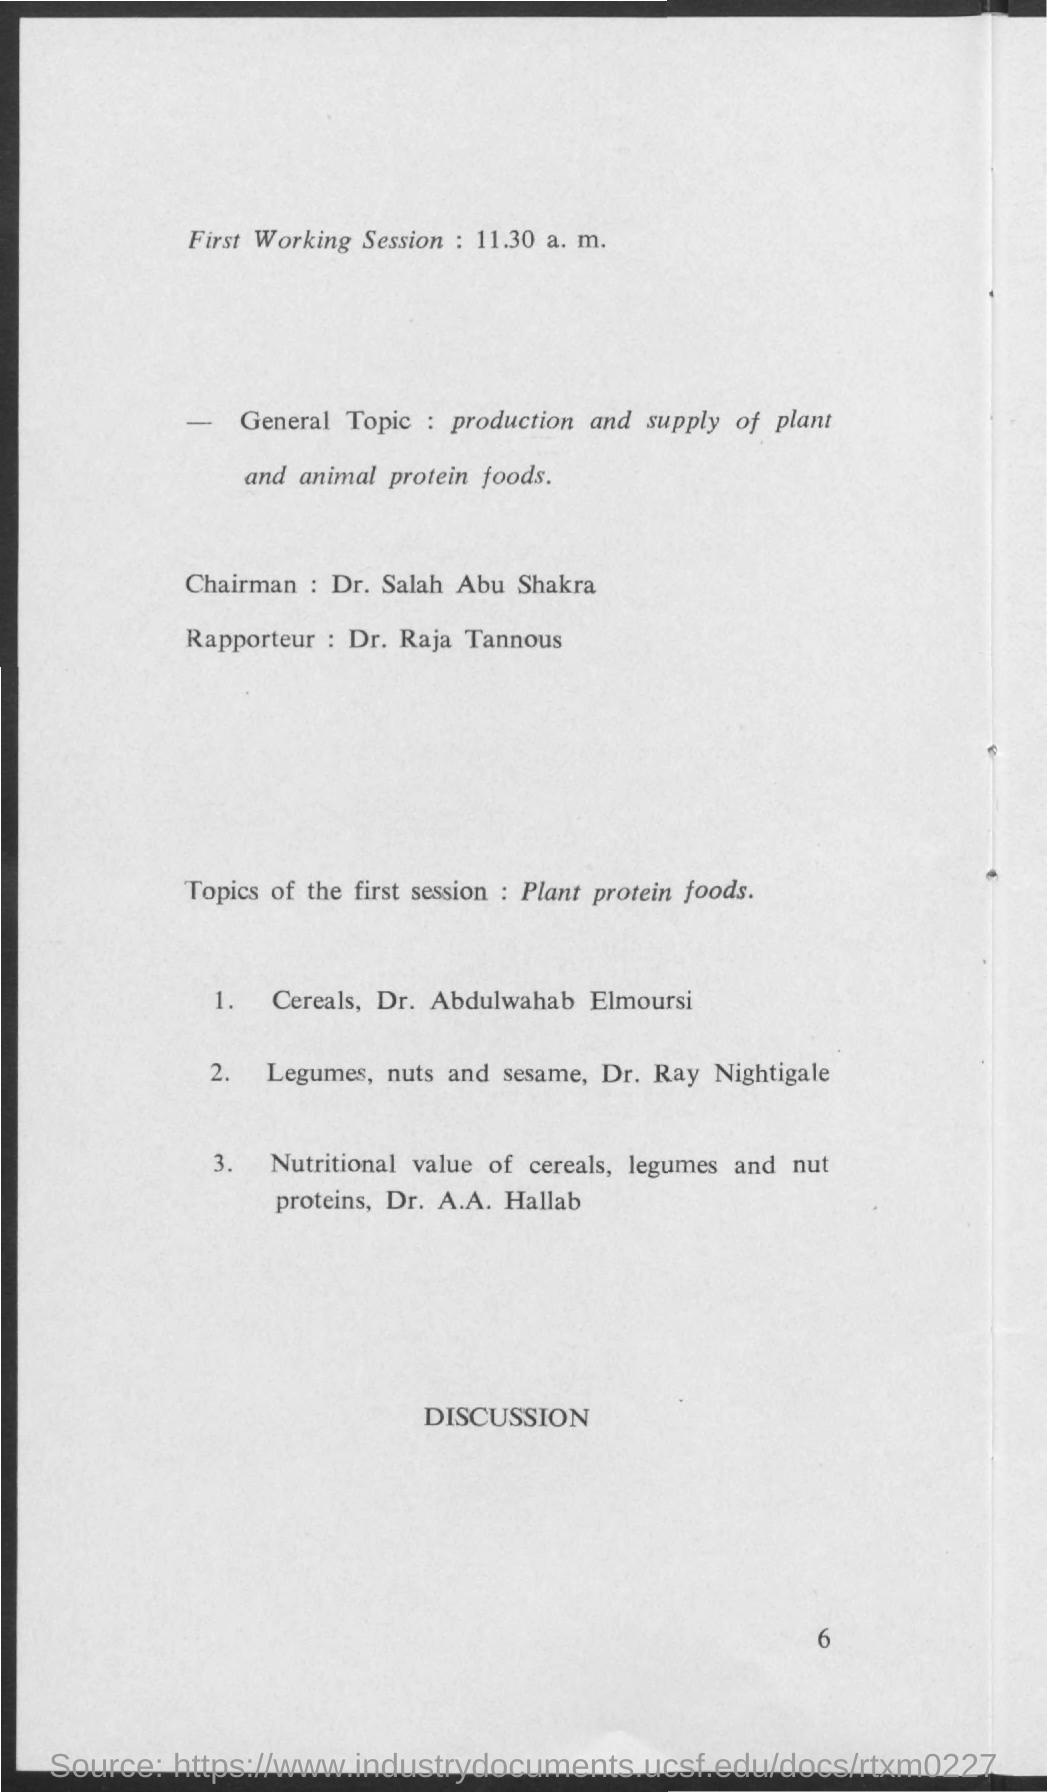What is the general topic mentioned ?
Ensure brevity in your answer.  Production and supply of plant and animal protein foods. What is the name of the chairman mentioned ?
Your response must be concise. Dr. Salah Abu Shakra. What is the name of the rapporteur mentioned ?
Provide a succinct answer. Dr. Raja Tannous. 